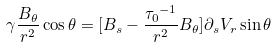Convert formula to latex. <formula><loc_0><loc_0><loc_500><loc_500>\gamma \frac { B _ { \theta } } { r ^ { 2 } } \cos { \theta } = [ B _ { s } - \frac { { { \tau } _ { 0 } } ^ { - 1 } } { r ^ { 2 } } B _ { \theta } ] { \partial } _ { s } V _ { r } \sin { \theta }</formula> 